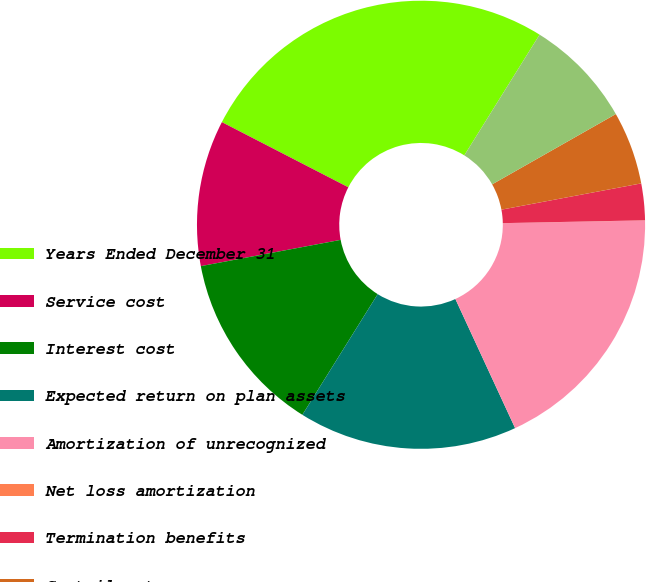Convert chart to OTSL. <chart><loc_0><loc_0><loc_500><loc_500><pie_chart><fcel>Years Ended December 31<fcel>Service cost<fcel>Interest cost<fcel>Expected return on plan assets<fcel>Amortization of unrecognized<fcel>Net loss amortization<fcel>Termination benefits<fcel>Curtailments<fcel>Net periodic benefit cost<nl><fcel>26.3%<fcel>10.53%<fcel>13.16%<fcel>15.78%<fcel>18.41%<fcel>0.01%<fcel>2.64%<fcel>5.27%<fcel>7.9%<nl></chart> 